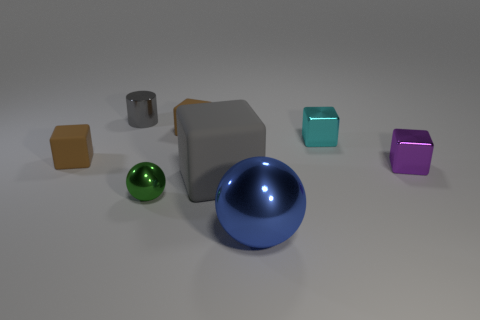Subtract 1 cubes. How many cubes are left? 4 Subtract all cyan blocks. How many blocks are left? 4 Subtract all big rubber cubes. How many cubes are left? 4 Add 2 yellow rubber cubes. How many objects exist? 10 Subtract all purple cubes. Subtract all brown cylinders. How many cubes are left? 4 Subtract all spheres. How many objects are left? 6 Add 2 tiny gray matte cylinders. How many tiny gray matte cylinders exist? 2 Subtract 0 gray spheres. How many objects are left? 8 Subtract all tiny red matte cubes. Subtract all small cyan shiny blocks. How many objects are left? 7 Add 8 blue shiny spheres. How many blue shiny spheres are left? 9 